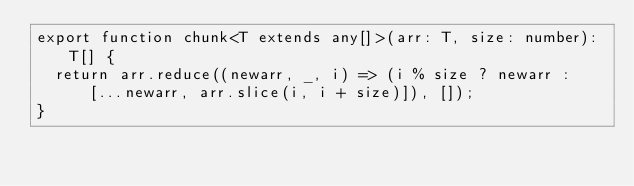<code> <loc_0><loc_0><loc_500><loc_500><_TypeScript_>export function chunk<T extends any[]>(arr: T, size: number): T[] {
  return arr.reduce((newarr, _, i) => (i % size ? newarr : [...newarr, arr.slice(i, i + size)]), []);
}
</code> 